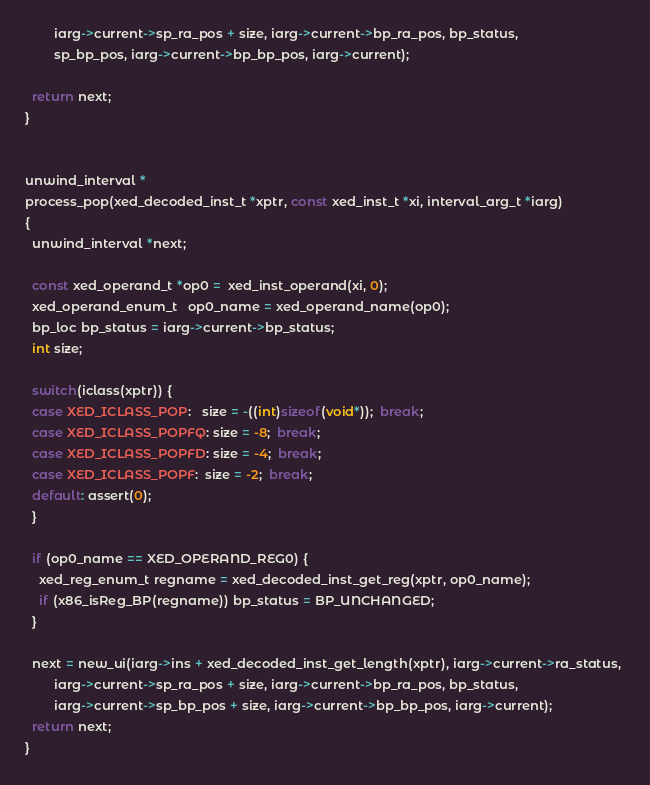<code> <loc_0><loc_0><loc_500><loc_500><_C_>		iarg->current->sp_ra_pos + size, iarg->current->bp_ra_pos, bp_status,
		sp_bp_pos, iarg->current->bp_bp_pos, iarg->current);

  return next;
}


unwind_interval *
process_pop(xed_decoded_inst_t *xptr, const xed_inst_t *xi, interval_arg_t *iarg)
{
  unwind_interval *next;

  const xed_operand_t *op0 =  xed_inst_operand(xi, 0);
  xed_operand_enum_t   op0_name = xed_operand_name(op0);
  bp_loc bp_status = iarg->current->bp_status;
  int size;

  switch(iclass(xptr)) {
  case XED_ICLASS_POP:   size = -((int)sizeof(void*));  break;  
  case XED_ICLASS_POPFQ: size = -8;  break;
  case XED_ICLASS_POPFD: size = -4;  break;
  case XED_ICLASS_POPF:  size = -2;  break;
  default: assert(0);
  }

  if (op0_name == XED_OPERAND_REG0) { 
    xed_reg_enum_t regname = xed_decoded_inst_get_reg(xptr, op0_name);
    if (x86_isReg_BP(regname)) bp_status = BP_UNCHANGED;
  }

  next = new_ui(iarg->ins + xed_decoded_inst_get_length(xptr), iarg->current->ra_status, 
		iarg->current->sp_ra_pos + size, iarg->current->bp_ra_pos, bp_status, 
		iarg->current->sp_bp_pos + size, iarg->current->bp_bp_pos, iarg->current);
  return next;
}
</code> 